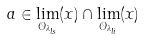<formula> <loc_0><loc_0><loc_500><loc_500>a \in \lim _ { { \mathcal { O } } _ { \lambda _ { l s } } } ( x ) \cap \lim _ { { \mathcal { O } } _ { \lambda _ { l i } } } ( x )</formula> 